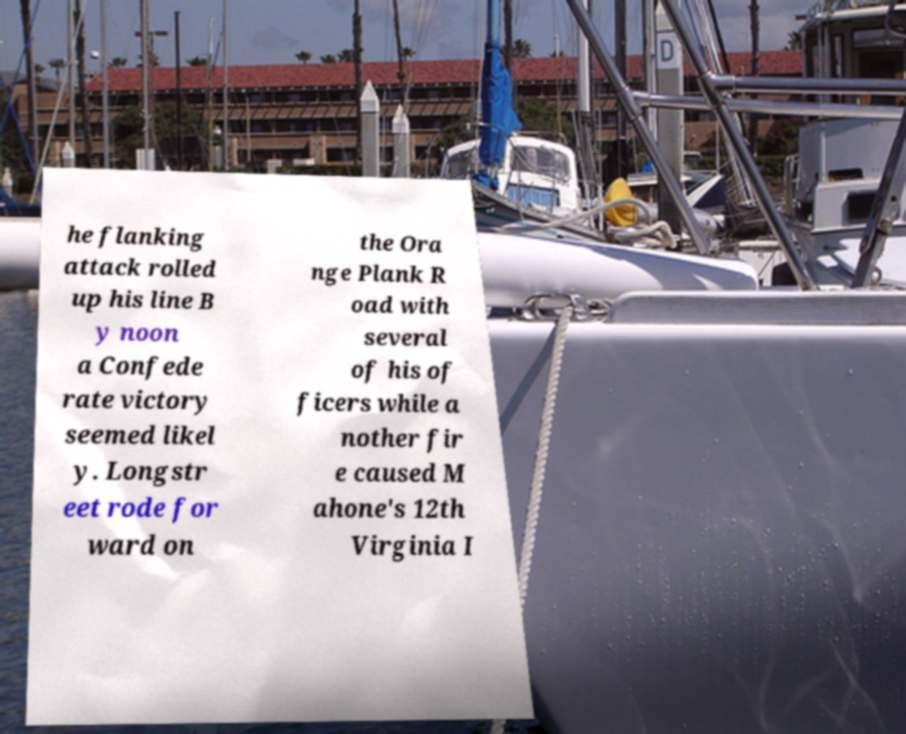Could you assist in decoding the text presented in this image and type it out clearly? he flanking attack rolled up his line B y noon a Confede rate victory seemed likel y. Longstr eet rode for ward on the Ora nge Plank R oad with several of his of ficers while a nother fir e caused M ahone's 12th Virginia I 